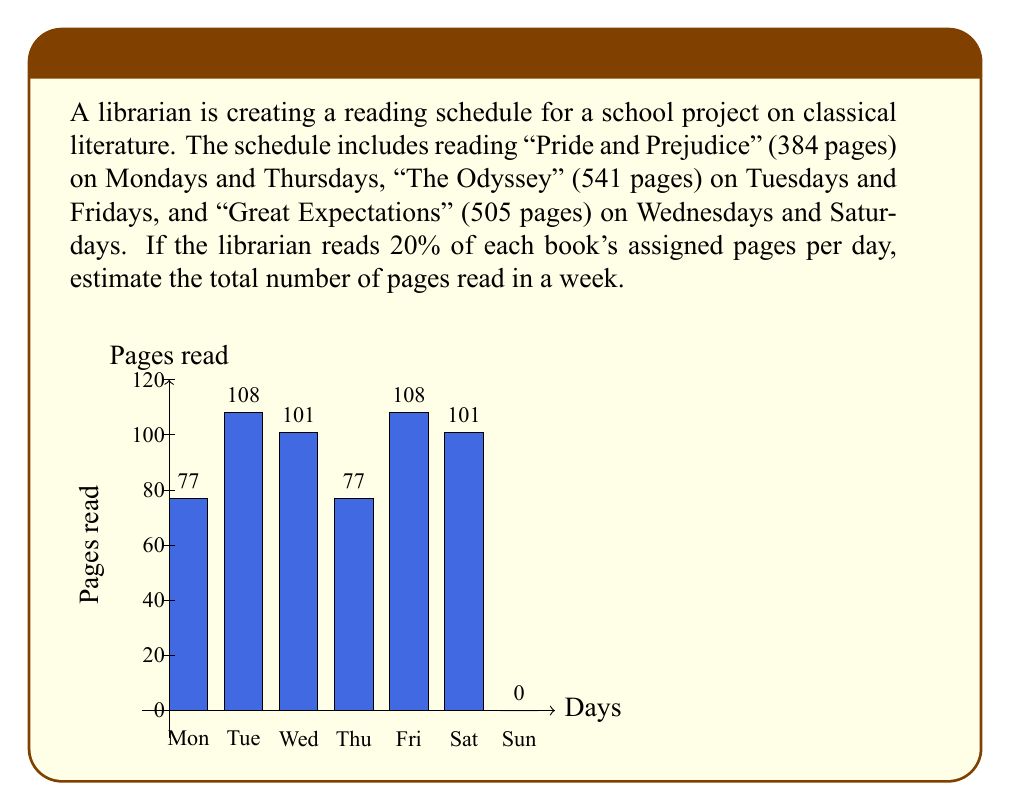Can you solve this math problem? Let's break this down step-by-step:

1) First, calculate 20% of each book's total pages:
   - "Pride and Prejudice": $384 \times 0.20 = 76.8$ pages
   - "The Odyssey": $541 \times 0.20 = 108.2$ pages
   - "Great Expectations": $505 \times 0.20 = 101$ pages

2) Now, let's count the pages read each day:
   - Monday: 76.8 pages (Pride and Prejudice)
   - Tuesday: 108.2 pages (The Odyssey)
   - Wednesday: 101 pages (Great Expectations)
   - Thursday: 76.8 pages (Pride and Prejudice)
   - Friday: 108.2 pages (The Odyssey)
   - Saturday: 101 pages (Great Expectations)
   - Sunday: 0 pages (no reading scheduled)

3) To get the total for the week, we sum up all these pages:

   $$ \text{Total} = 76.8 + 108.2 + 101 + 76.8 + 108.2 + 101 + 0 = 572 $$

4) Since we're asked for an estimate, we can round this to the nearest whole number:

   $$ \text{Estimated total} \approx 572 \text{ pages} $$
Answer: 572 pages 